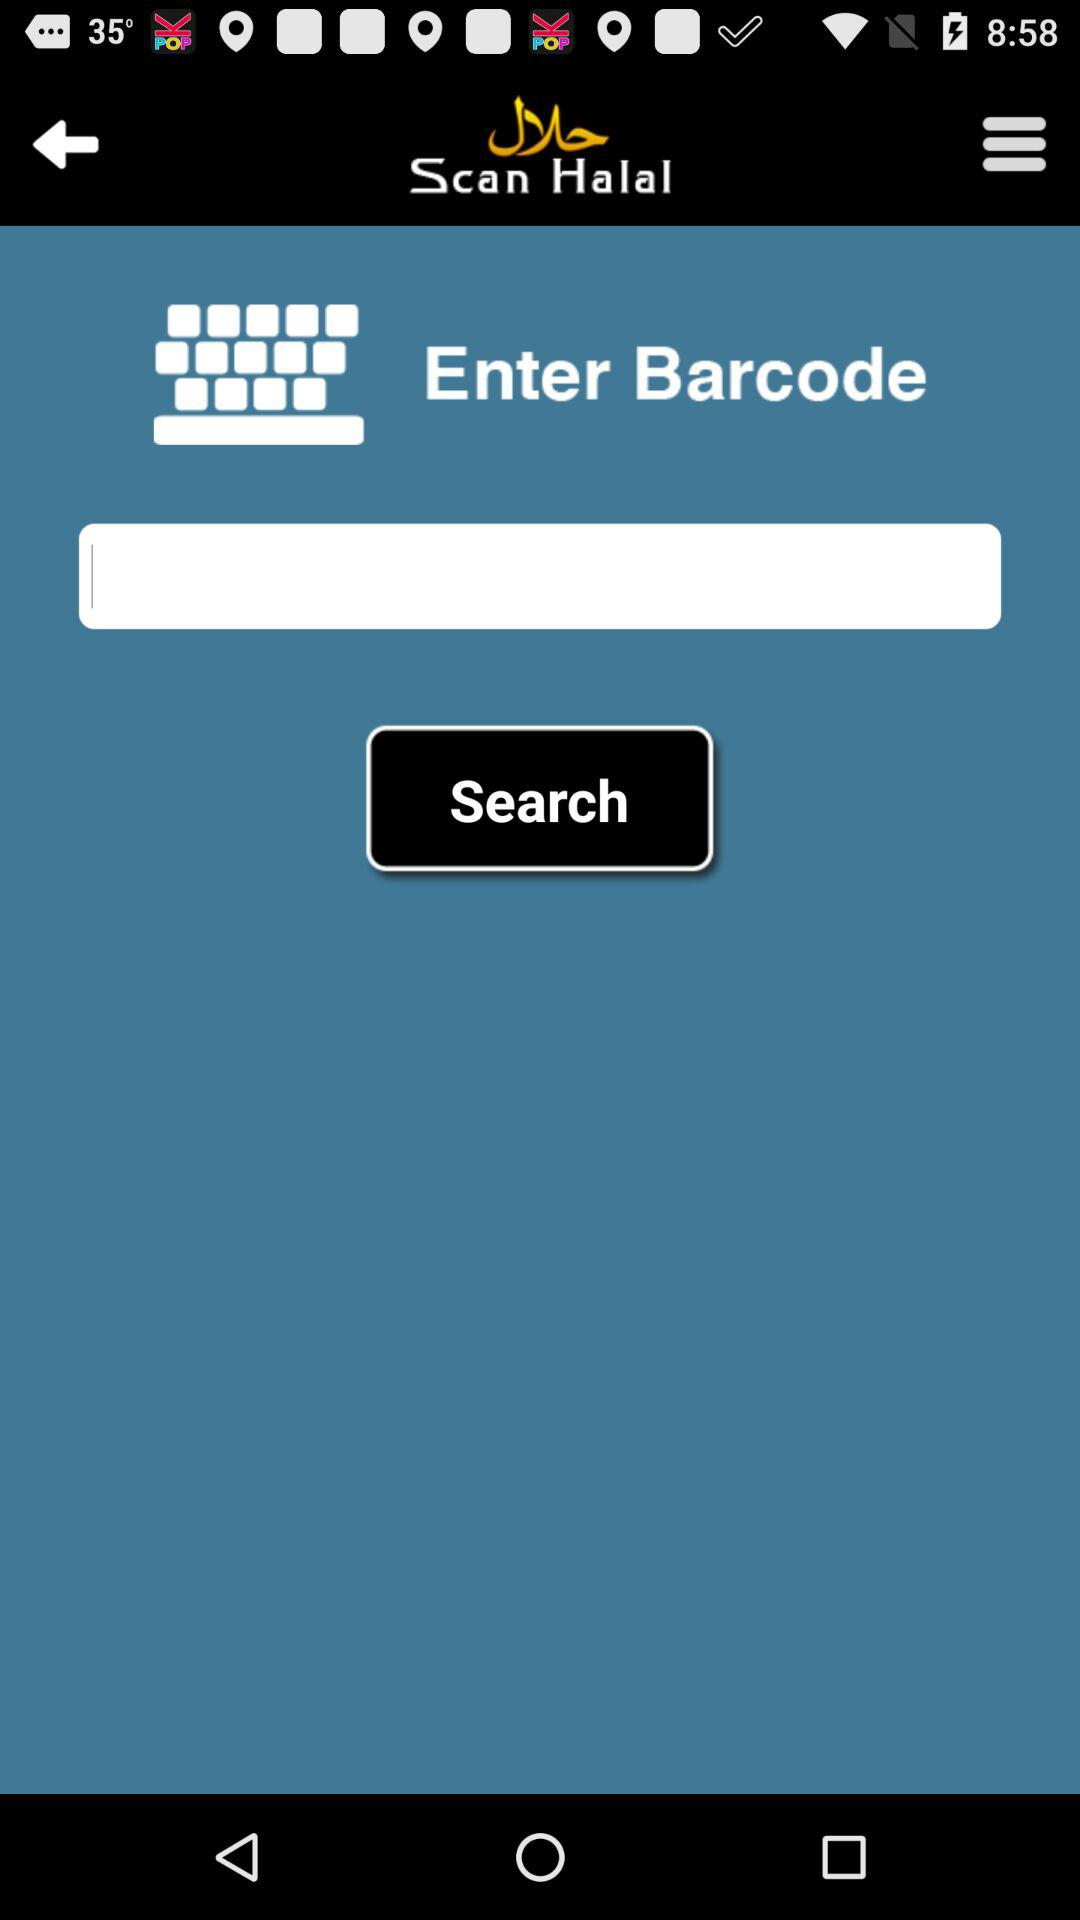What is the application name? The application name is "Scan Halal". 